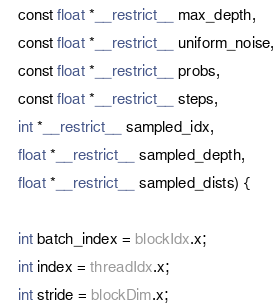<code> <loc_0><loc_0><loc_500><loc_500><_Cuda_>    const float *__restrict__ max_depth,
    const float *__restrict__ uniform_noise,
    const float *__restrict__ probs,
    const float *__restrict__ steps,
    int *__restrict__ sampled_idx,
    float *__restrict__ sampled_depth,
    float *__restrict__ sampled_dists) {

    int batch_index = blockIdx.x;
    int index = threadIdx.x;
    int stride = blockDim.x;
</code> 